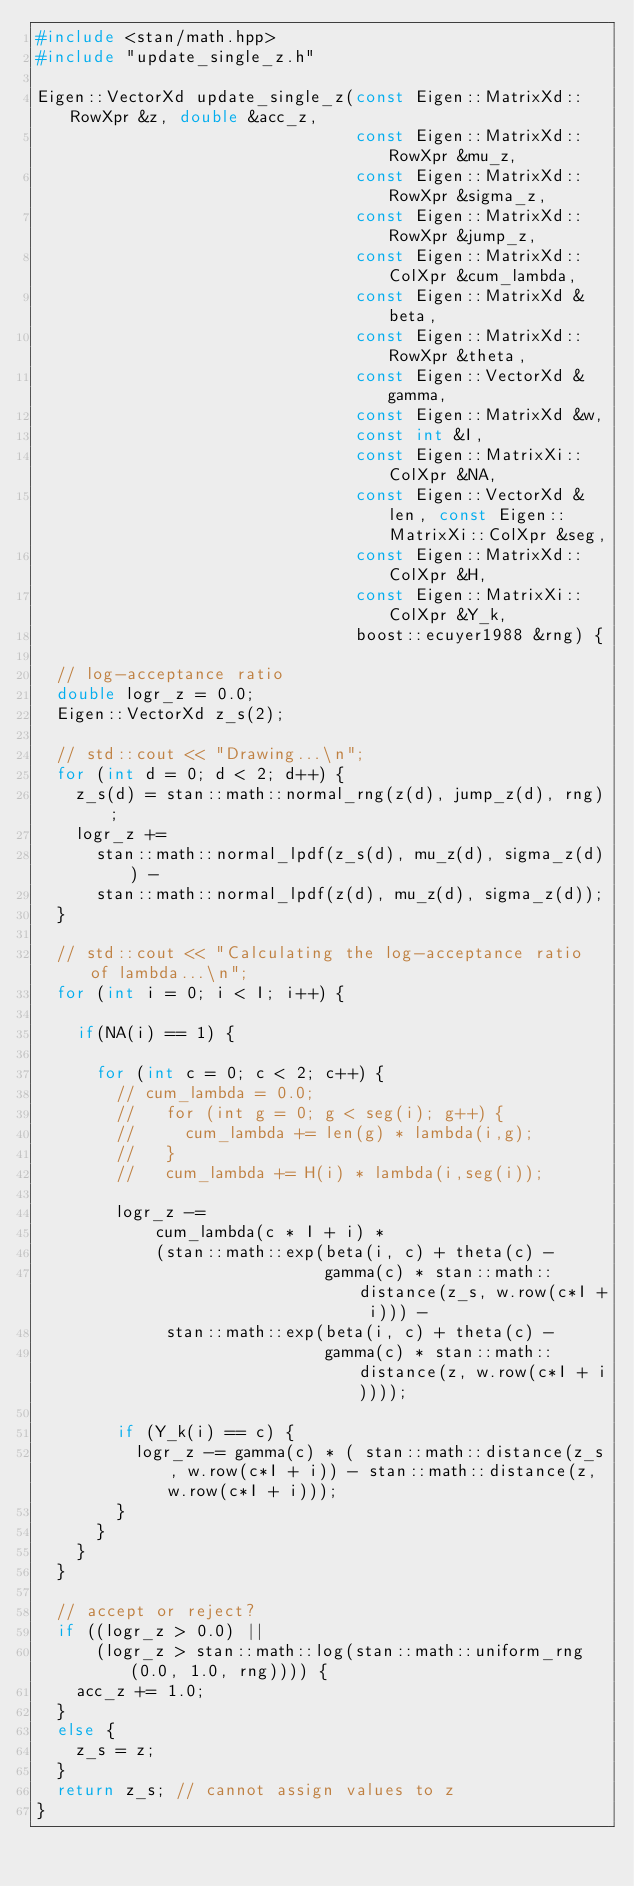Convert code to text. <code><loc_0><loc_0><loc_500><loc_500><_C++_>#include <stan/math.hpp>
#include "update_single_z.h"

Eigen::VectorXd update_single_z(const Eigen::MatrixXd::RowXpr &z, double &acc_z,
                                const Eigen::MatrixXd::RowXpr &mu_z,
                                const Eigen::MatrixXd::RowXpr &sigma_z,
                                const Eigen::MatrixXd::RowXpr &jump_z,
                                const Eigen::MatrixXd::ColXpr &cum_lambda,
                                const Eigen::MatrixXd &beta,
                                const Eigen::MatrixXd::RowXpr &theta,
                                const Eigen::VectorXd &gamma,
                                const Eigen::MatrixXd &w,
                                const int &I,
                                const Eigen::MatrixXi::ColXpr &NA,
                                const Eigen::VectorXd &len, const Eigen::MatrixXi::ColXpr &seg,
                                const Eigen::MatrixXd::ColXpr &H,
                                const Eigen::MatrixXi::ColXpr &Y_k,
                                boost::ecuyer1988 &rng) {

  // log-acceptance ratio
  double logr_z = 0.0;
  Eigen::VectorXd z_s(2);

  // std::cout << "Drawing...\n";
  for (int d = 0; d < 2; d++) {
    z_s(d) = stan::math::normal_rng(z(d), jump_z(d), rng);
    logr_z +=
      stan::math::normal_lpdf(z_s(d), mu_z(d), sigma_z(d)) -
      stan::math::normal_lpdf(z(d), mu_z(d), sigma_z(d));
  }

  // std::cout << "Calculating the log-acceptance ratio of lambda...\n";
  for (int i = 0; i < I; i++) {

    if(NA(i) == 1) {

      for (int c = 0; c < 2; c++) {
        // cum_lambda = 0.0;
        //   for (int g = 0; g < seg(i); g++) {
        //     cum_lambda += len(g) * lambda(i,g);
        //   }
        //   cum_lambda += H(i) * lambda(i,seg(i));

        logr_z -=
            cum_lambda(c * I + i) *
            (stan::math::exp(beta(i, c) + theta(c) -
                             gamma(c) * stan::math::distance(z_s, w.row(c*I + i))) -
             stan::math::exp(beta(i, c) + theta(c) -
                             gamma(c) * stan::math::distance(z, w.row(c*I + i))));

        if (Y_k(i) == c) {
          logr_z -= gamma(c) * ( stan::math::distance(z_s, w.row(c*I + i)) - stan::math::distance(z, w.row(c*I + i)));
        }
      }
    }
  }

  // accept or reject?
  if ((logr_z > 0.0) ||
      (logr_z > stan::math::log(stan::math::uniform_rng(0.0, 1.0, rng)))) {
    acc_z += 1.0;
  }
  else {
    z_s = z;
  }
  return z_s; // cannot assign values to z
}
</code> 